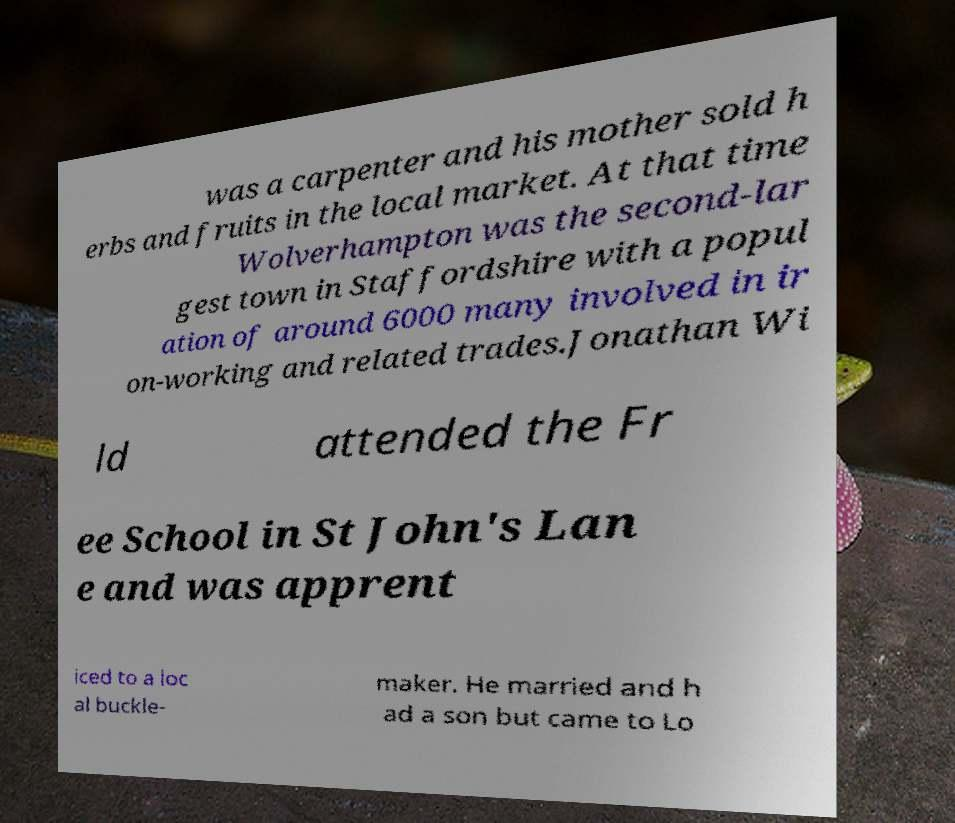I need the written content from this picture converted into text. Can you do that? was a carpenter and his mother sold h erbs and fruits in the local market. At that time Wolverhampton was the second-lar gest town in Staffordshire with a popul ation of around 6000 many involved in ir on-working and related trades.Jonathan Wi ld attended the Fr ee School in St John's Lan e and was apprent iced to a loc al buckle- maker. He married and h ad a son but came to Lo 